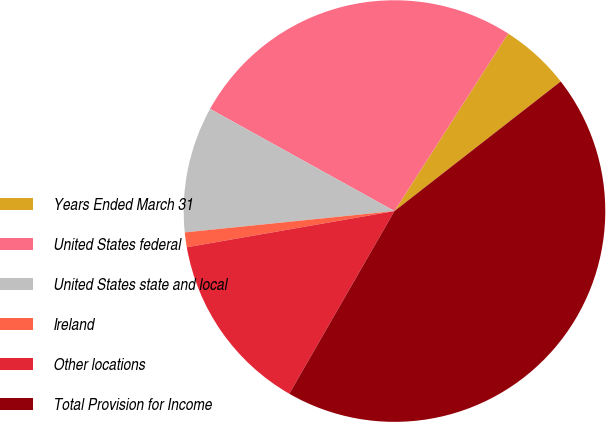<chart> <loc_0><loc_0><loc_500><loc_500><pie_chart><fcel>Years Ended March 31<fcel>United States federal<fcel>United States state and local<fcel>Ireland<fcel>Other locations<fcel>Total Provision for Income<nl><fcel>5.4%<fcel>26.01%<fcel>9.67%<fcel>1.13%<fcel>13.94%<fcel>43.85%<nl></chart> 